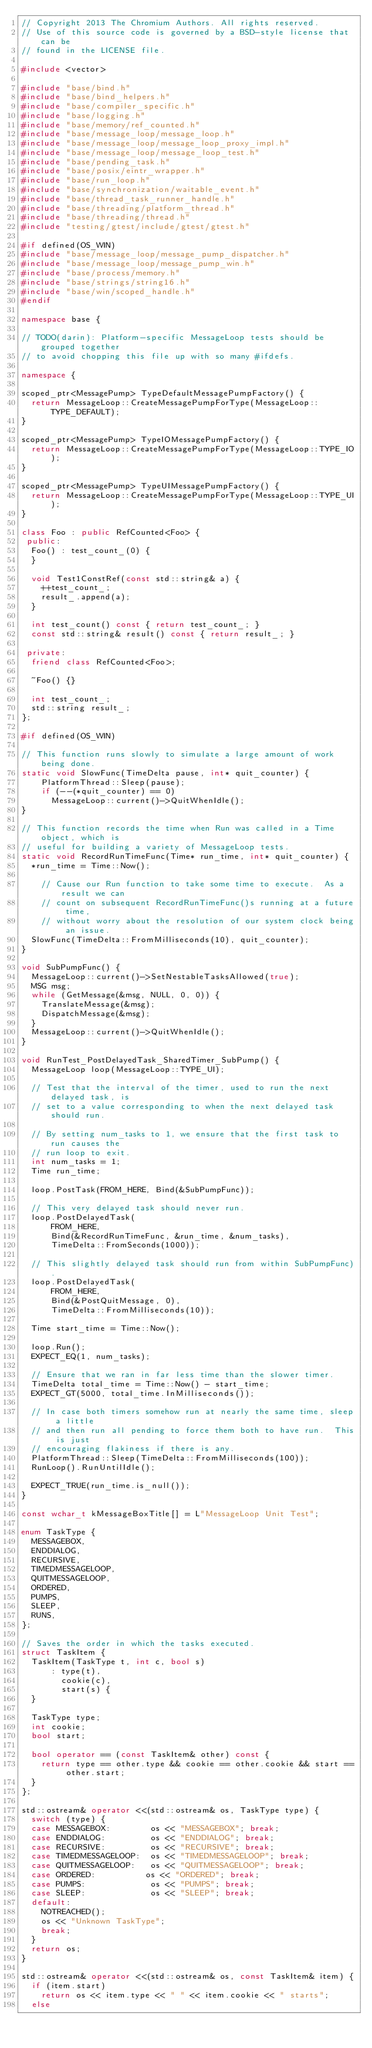Convert code to text. <code><loc_0><loc_0><loc_500><loc_500><_C++_>// Copyright 2013 The Chromium Authors. All rights reserved.
// Use of this source code is governed by a BSD-style license that can be
// found in the LICENSE file.

#include <vector>

#include "base/bind.h"
#include "base/bind_helpers.h"
#include "base/compiler_specific.h"
#include "base/logging.h"
#include "base/memory/ref_counted.h"
#include "base/message_loop/message_loop.h"
#include "base/message_loop/message_loop_proxy_impl.h"
#include "base/message_loop/message_loop_test.h"
#include "base/pending_task.h"
#include "base/posix/eintr_wrapper.h"
#include "base/run_loop.h"
#include "base/synchronization/waitable_event.h"
#include "base/thread_task_runner_handle.h"
#include "base/threading/platform_thread.h"
#include "base/threading/thread.h"
#include "testing/gtest/include/gtest/gtest.h"

#if defined(OS_WIN)
#include "base/message_loop/message_pump_dispatcher.h"
#include "base/message_loop/message_pump_win.h"
#include "base/process/memory.h"
#include "base/strings/string16.h"
#include "base/win/scoped_handle.h"
#endif

namespace base {

// TODO(darin): Platform-specific MessageLoop tests should be grouped together
// to avoid chopping this file up with so many #ifdefs.

namespace {

scoped_ptr<MessagePump> TypeDefaultMessagePumpFactory() {
  return MessageLoop::CreateMessagePumpForType(MessageLoop::TYPE_DEFAULT);
}

scoped_ptr<MessagePump> TypeIOMessagePumpFactory() {
  return MessageLoop::CreateMessagePumpForType(MessageLoop::TYPE_IO);
}

scoped_ptr<MessagePump> TypeUIMessagePumpFactory() {
  return MessageLoop::CreateMessagePumpForType(MessageLoop::TYPE_UI);
}

class Foo : public RefCounted<Foo> {
 public:
  Foo() : test_count_(0) {
  }

  void Test1ConstRef(const std::string& a) {
    ++test_count_;
    result_.append(a);
  }

  int test_count() const { return test_count_; }
  const std::string& result() const { return result_; }

 private:
  friend class RefCounted<Foo>;

  ~Foo() {}

  int test_count_;
  std::string result_;
};

#if defined(OS_WIN)

// This function runs slowly to simulate a large amount of work being done.
static void SlowFunc(TimeDelta pause, int* quit_counter) {
    PlatformThread::Sleep(pause);
    if (--(*quit_counter) == 0)
      MessageLoop::current()->QuitWhenIdle();
}

// This function records the time when Run was called in a Time object, which is
// useful for building a variety of MessageLoop tests.
static void RecordRunTimeFunc(Time* run_time, int* quit_counter) {
  *run_time = Time::Now();

    // Cause our Run function to take some time to execute.  As a result we can
    // count on subsequent RecordRunTimeFunc()s running at a future time,
    // without worry about the resolution of our system clock being an issue.
  SlowFunc(TimeDelta::FromMilliseconds(10), quit_counter);
}

void SubPumpFunc() {
  MessageLoop::current()->SetNestableTasksAllowed(true);
  MSG msg;
  while (GetMessage(&msg, NULL, 0, 0)) {
    TranslateMessage(&msg);
    DispatchMessage(&msg);
  }
  MessageLoop::current()->QuitWhenIdle();
}

void RunTest_PostDelayedTask_SharedTimer_SubPump() {
  MessageLoop loop(MessageLoop::TYPE_UI);

  // Test that the interval of the timer, used to run the next delayed task, is
  // set to a value corresponding to when the next delayed task should run.

  // By setting num_tasks to 1, we ensure that the first task to run causes the
  // run loop to exit.
  int num_tasks = 1;
  Time run_time;

  loop.PostTask(FROM_HERE, Bind(&SubPumpFunc));

  // This very delayed task should never run.
  loop.PostDelayedTask(
      FROM_HERE,
      Bind(&RecordRunTimeFunc, &run_time, &num_tasks),
      TimeDelta::FromSeconds(1000));

  // This slightly delayed task should run from within SubPumpFunc).
  loop.PostDelayedTask(
      FROM_HERE,
      Bind(&PostQuitMessage, 0),
      TimeDelta::FromMilliseconds(10));

  Time start_time = Time::Now();

  loop.Run();
  EXPECT_EQ(1, num_tasks);

  // Ensure that we ran in far less time than the slower timer.
  TimeDelta total_time = Time::Now() - start_time;
  EXPECT_GT(5000, total_time.InMilliseconds());

  // In case both timers somehow run at nearly the same time, sleep a little
  // and then run all pending to force them both to have run.  This is just
  // encouraging flakiness if there is any.
  PlatformThread::Sleep(TimeDelta::FromMilliseconds(100));
  RunLoop().RunUntilIdle();

  EXPECT_TRUE(run_time.is_null());
}

const wchar_t kMessageBoxTitle[] = L"MessageLoop Unit Test";

enum TaskType {
  MESSAGEBOX,
  ENDDIALOG,
  RECURSIVE,
  TIMEDMESSAGELOOP,
  QUITMESSAGELOOP,
  ORDERED,
  PUMPS,
  SLEEP,
  RUNS,
};

// Saves the order in which the tasks executed.
struct TaskItem {
  TaskItem(TaskType t, int c, bool s)
      : type(t),
        cookie(c),
        start(s) {
  }

  TaskType type;
  int cookie;
  bool start;

  bool operator == (const TaskItem& other) const {
    return type == other.type && cookie == other.cookie && start == other.start;
  }
};

std::ostream& operator <<(std::ostream& os, TaskType type) {
  switch (type) {
  case MESSAGEBOX:        os << "MESSAGEBOX"; break;
  case ENDDIALOG:         os << "ENDDIALOG"; break;
  case RECURSIVE:         os << "RECURSIVE"; break;
  case TIMEDMESSAGELOOP:  os << "TIMEDMESSAGELOOP"; break;
  case QUITMESSAGELOOP:   os << "QUITMESSAGELOOP"; break;
  case ORDERED:          os << "ORDERED"; break;
  case PUMPS:             os << "PUMPS"; break;
  case SLEEP:             os << "SLEEP"; break;
  default:
    NOTREACHED();
    os << "Unknown TaskType";
    break;
  }
  return os;
}

std::ostream& operator <<(std::ostream& os, const TaskItem& item) {
  if (item.start)
    return os << item.type << " " << item.cookie << " starts";
  else</code> 